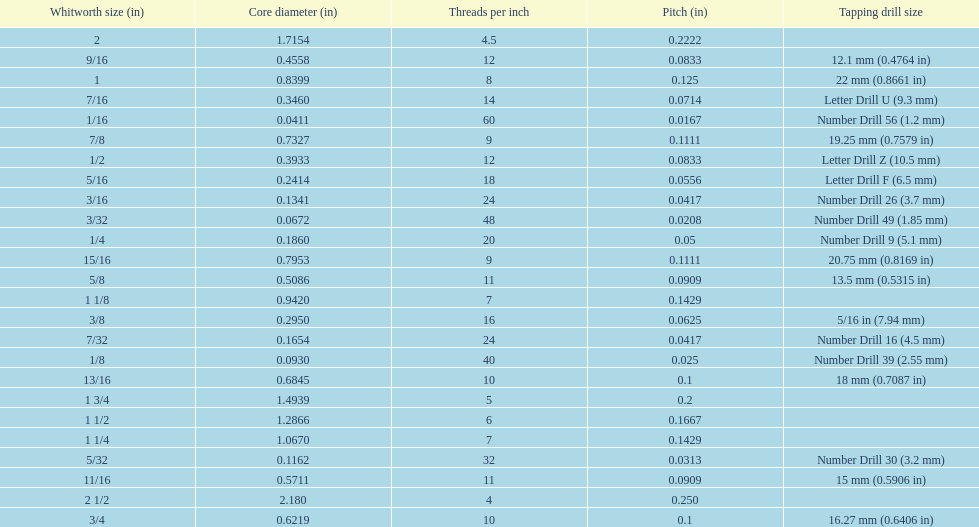How many threads per inch does a 9/16 have? 12. 